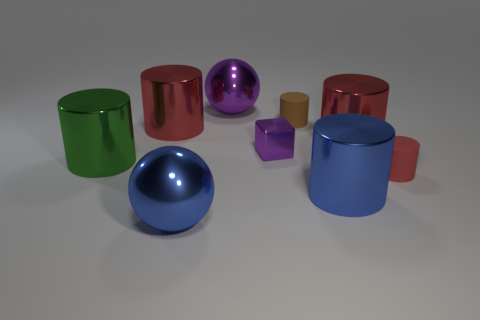Do the brown rubber object and the large purple object have the same shape? no 